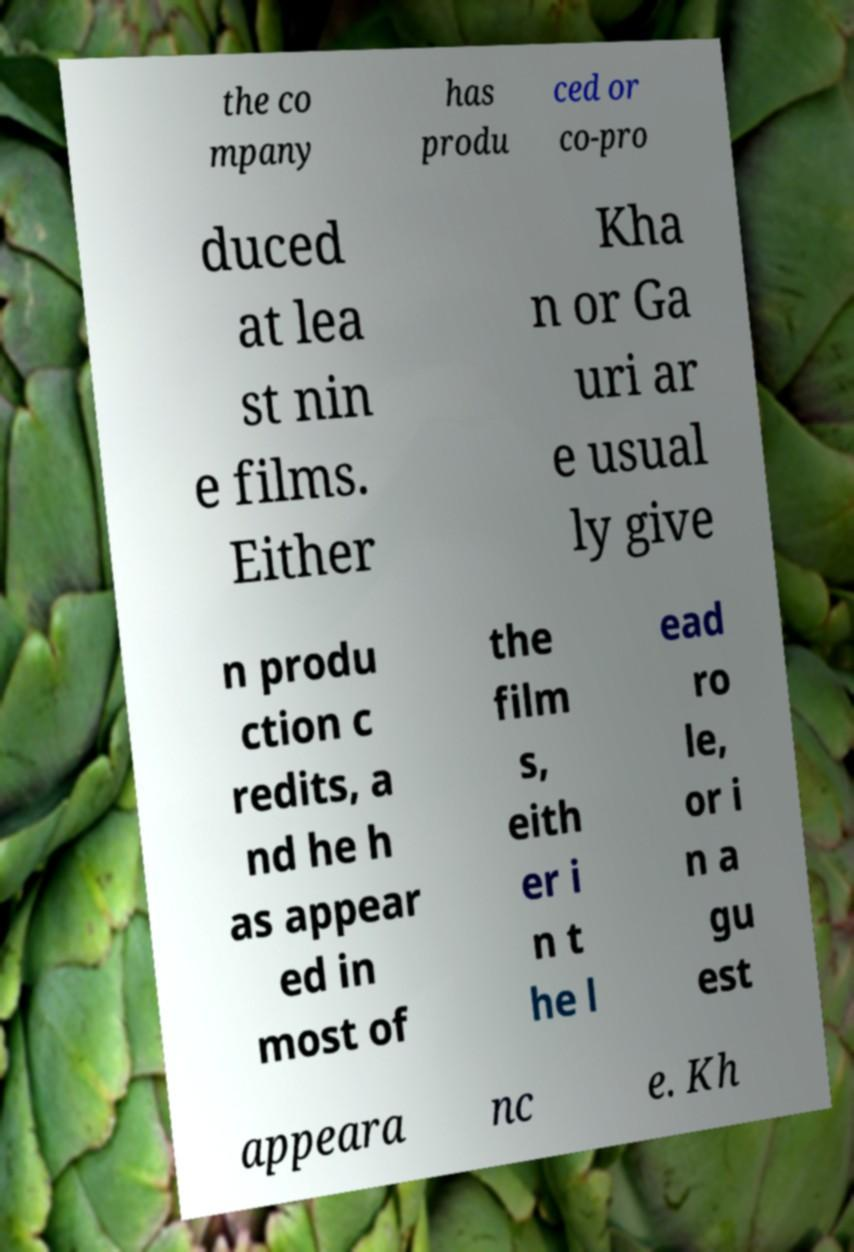I need the written content from this picture converted into text. Can you do that? the co mpany has produ ced or co-pro duced at lea st nin e films. Either Kha n or Ga uri ar e usual ly give n produ ction c redits, a nd he h as appear ed in most of the film s, eith er i n t he l ead ro le, or i n a gu est appeara nc e. Kh 